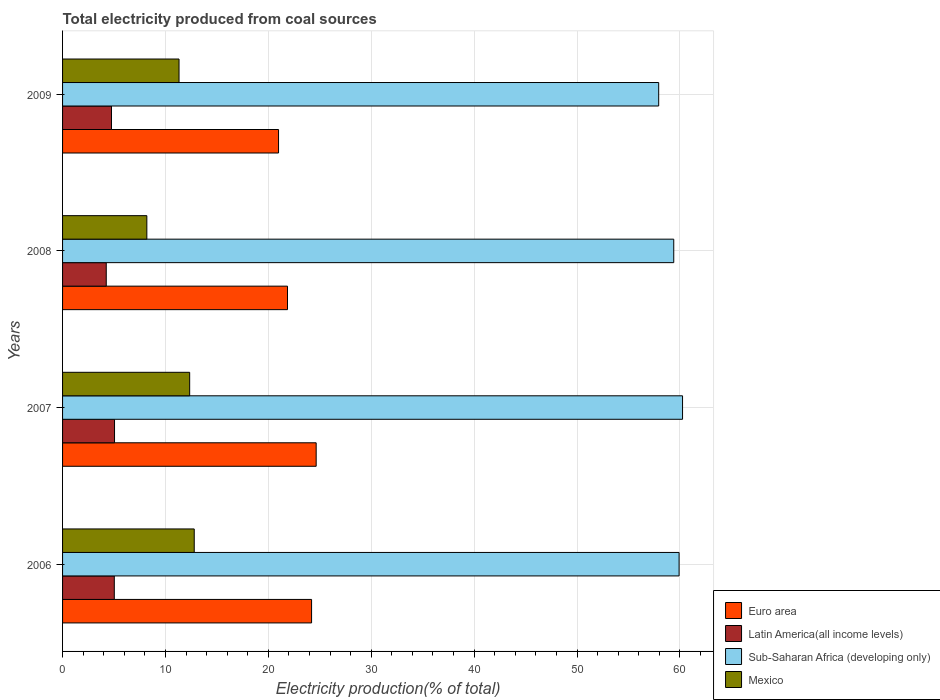How many different coloured bars are there?
Your response must be concise. 4. Are the number of bars per tick equal to the number of legend labels?
Ensure brevity in your answer.  Yes. How many bars are there on the 3rd tick from the top?
Your response must be concise. 4. How many bars are there on the 3rd tick from the bottom?
Offer a very short reply. 4. In how many cases, is the number of bars for a given year not equal to the number of legend labels?
Ensure brevity in your answer.  0. What is the total electricity produced in Sub-Saharan Africa (developing only) in 2006?
Ensure brevity in your answer.  59.92. Across all years, what is the maximum total electricity produced in Latin America(all income levels)?
Your answer should be very brief. 5.05. Across all years, what is the minimum total electricity produced in Latin America(all income levels)?
Make the answer very short. 4.25. In which year was the total electricity produced in Sub-Saharan Africa (developing only) minimum?
Offer a terse response. 2009. What is the total total electricity produced in Latin America(all income levels) in the graph?
Your answer should be very brief. 19.08. What is the difference between the total electricity produced in Latin America(all income levels) in 2007 and that in 2009?
Your answer should be compact. 0.3. What is the difference between the total electricity produced in Euro area in 2008 and the total electricity produced in Mexico in 2007?
Ensure brevity in your answer.  9.51. What is the average total electricity produced in Euro area per year?
Make the answer very short. 22.93. In the year 2009, what is the difference between the total electricity produced in Sub-Saharan Africa (developing only) and total electricity produced in Latin America(all income levels)?
Keep it short and to the point. 53.18. What is the ratio of the total electricity produced in Sub-Saharan Africa (developing only) in 2006 to that in 2009?
Your response must be concise. 1.03. Is the total electricity produced in Sub-Saharan Africa (developing only) in 2006 less than that in 2008?
Your response must be concise. No. Is the difference between the total electricity produced in Sub-Saharan Africa (developing only) in 2006 and 2009 greater than the difference between the total electricity produced in Latin America(all income levels) in 2006 and 2009?
Your answer should be very brief. Yes. What is the difference between the highest and the second highest total electricity produced in Euro area?
Offer a very short reply. 0.45. What is the difference between the highest and the lowest total electricity produced in Mexico?
Keep it short and to the point. 4.61. In how many years, is the total electricity produced in Sub-Saharan Africa (developing only) greater than the average total electricity produced in Sub-Saharan Africa (developing only) taken over all years?
Give a very brief answer. 3. What does the 1st bar from the top in 2008 represents?
Offer a very short reply. Mexico. What does the 2nd bar from the bottom in 2006 represents?
Make the answer very short. Latin America(all income levels). What is the difference between two consecutive major ticks on the X-axis?
Your answer should be compact. 10. Are the values on the major ticks of X-axis written in scientific E-notation?
Give a very brief answer. No. How many legend labels are there?
Provide a succinct answer. 4. How are the legend labels stacked?
Give a very brief answer. Vertical. What is the title of the graph?
Ensure brevity in your answer.  Total electricity produced from coal sources. What is the Electricity production(% of total) in Euro area in 2006?
Offer a very short reply. 24.2. What is the Electricity production(% of total) of Latin America(all income levels) in 2006?
Ensure brevity in your answer.  5.03. What is the Electricity production(% of total) in Sub-Saharan Africa (developing only) in 2006?
Provide a short and direct response. 59.92. What is the Electricity production(% of total) in Mexico in 2006?
Ensure brevity in your answer.  12.8. What is the Electricity production(% of total) in Euro area in 2007?
Your answer should be compact. 24.65. What is the Electricity production(% of total) in Latin America(all income levels) in 2007?
Your answer should be compact. 5.05. What is the Electricity production(% of total) of Sub-Saharan Africa (developing only) in 2007?
Your answer should be compact. 60.25. What is the Electricity production(% of total) in Mexico in 2007?
Offer a very short reply. 12.35. What is the Electricity production(% of total) in Euro area in 2008?
Ensure brevity in your answer.  21.86. What is the Electricity production(% of total) of Latin America(all income levels) in 2008?
Provide a short and direct response. 4.25. What is the Electricity production(% of total) of Sub-Saharan Africa (developing only) in 2008?
Provide a succinct answer. 59.4. What is the Electricity production(% of total) in Mexico in 2008?
Give a very brief answer. 8.19. What is the Electricity production(% of total) in Euro area in 2009?
Provide a succinct answer. 20.99. What is the Electricity production(% of total) in Latin America(all income levels) in 2009?
Your answer should be very brief. 4.75. What is the Electricity production(% of total) in Sub-Saharan Africa (developing only) in 2009?
Your response must be concise. 57.94. What is the Electricity production(% of total) in Mexico in 2009?
Ensure brevity in your answer.  11.32. Across all years, what is the maximum Electricity production(% of total) in Euro area?
Make the answer very short. 24.65. Across all years, what is the maximum Electricity production(% of total) in Latin America(all income levels)?
Provide a short and direct response. 5.05. Across all years, what is the maximum Electricity production(% of total) in Sub-Saharan Africa (developing only)?
Your response must be concise. 60.25. Across all years, what is the maximum Electricity production(% of total) in Mexico?
Your response must be concise. 12.8. Across all years, what is the minimum Electricity production(% of total) in Euro area?
Provide a short and direct response. 20.99. Across all years, what is the minimum Electricity production(% of total) in Latin America(all income levels)?
Offer a very short reply. 4.25. Across all years, what is the minimum Electricity production(% of total) in Sub-Saharan Africa (developing only)?
Provide a succinct answer. 57.94. Across all years, what is the minimum Electricity production(% of total) of Mexico?
Provide a succinct answer. 8.19. What is the total Electricity production(% of total) of Euro area in the graph?
Make the answer very short. 91.7. What is the total Electricity production(% of total) in Latin America(all income levels) in the graph?
Your answer should be very brief. 19.08. What is the total Electricity production(% of total) in Sub-Saharan Africa (developing only) in the graph?
Give a very brief answer. 237.51. What is the total Electricity production(% of total) in Mexico in the graph?
Provide a succinct answer. 44.66. What is the difference between the Electricity production(% of total) of Euro area in 2006 and that in 2007?
Your response must be concise. -0.45. What is the difference between the Electricity production(% of total) in Latin America(all income levels) in 2006 and that in 2007?
Keep it short and to the point. -0.02. What is the difference between the Electricity production(% of total) of Sub-Saharan Africa (developing only) in 2006 and that in 2007?
Make the answer very short. -0.33. What is the difference between the Electricity production(% of total) of Mexico in 2006 and that in 2007?
Keep it short and to the point. 0.44. What is the difference between the Electricity production(% of total) in Euro area in 2006 and that in 2008?
Make the answer very short. 2.34. What is the difference between the Electricity production(% of total) in Latin America(all income levels) in 2006 and that in 2008?
Provide a succinct answer. 0.78. What is the difference between the Electricity production(% of total) in Sub-Saharan Africa (developing only) in 2006 and that in 2008?
Your response must be concise. 0.52. What is the difference between the Electricity production(% of total) of Mexico in 2006 and that in 2008?
Offer a terse response. 4.61. What is the difference between the Electricity production(% of total) in Euro area in 2006 and that in 2009?
Provide a short and direct response. 3.21. What is the difference between the Electricity production(% of total) of Latin America(all income levels) in 2006 and that in 2009?
Offer a terse response. 0.27. What is the difference between the Electricity production(% of total) in Sub-Saharan Africa (developing only) in 2006 and that in 2009?
Provide a succinct answer. 1.98. What is the difference between the Electricity production(% of total) of Mexico in 2006 and that in 2009?
Your answer should be very brief. 1.48. What is the difference between the Electricity production(% of total) of Euro area in 2007 and that in 2008?
Ensure brevity in your answer.  2.79. What is the difference between the Electricity production(% of total) in Latin America(all income levels) in 2007 and that in 2008?
Provide a short and direct response. 0.8. What is the difference between the Electricity production(% of total) in Sub-Saharan Africa (developing only) in 2007 and that in 2008?
Give a very brief answer. 0.85. What is the difference between the Electricity production(% of total) of Mexico in 2007 and that in 2008?
Give a very brief answer. 4.16. What is the difference between the Electricity production(% of total) of Euro area in 2007 and that in 2009?
Provide a succinct answer. 3.66. What is the difference between the Electricity production(% of total) of Latin America(all income levels) in 2007 and that in 2009?
Give a very brief answer. 0.3. What is the difference between the Electricity production(% of total) in Sub-Saharan Africa (developing only) in 2007 and that in 2009?
Provide a short and direct response. 2.32. What is the difference between the Electricity production(% of total) of Mexico in 2007 and that in 2009?
Offer a very short reply. 1.03. What is the difference between the Electricity production(% of total) in Euro area in 2008 and that in 2009?
Give a very brief answer. 0.87. What is the difference between the Electricity production(% of total) in Latin America(all income levels) in 2008 and that in 2009?
Offer a very short reply. -0.51. What is the difference between the Electricity production(% of total) in Sub-Saharan Africa (developing only) in 2008 and that in 2009?
Give a very brief answer. 1.46. What is the difference between the Electricity production(% of total) in Mexico in 2008 and that in 2009?
Offer a terse response. -3.13. What is the difference between the Electricity production(% of total) in Euro area in 2006 and the Electricity production(% of total) in Latin America(all income levels) in 2007?
Offer a terse response. 19.15. What is the difference between the Electricity production(% of total) in Euro area in 2006 and the Electricity production(% of total) in Sub-Saharan Africa (developing only) in 2007?
Provide a succinct answer. -36.05. What is the difference between the Electricity production(% of total) in Euro area in 2006 and the Electricity production(% of total) in Mexico in 2007?
Offer a terse response. 11.85. What is the difference between the Electricity production(% of total) in Latin America(all income levels) in 2006 and the Electricity production(% of total) in Sub-Saharan Africa (developing only) in 2007?
Your answer should be compact. -55.23. What is the difference between the Electricity production(% of total) in Latin America(all income levels) in 2006 and the Electricity production(% of total) in Mexico in 2007?
Your answer should be compact. -7.33. What is the difference between the Electricity production(% of total) in Sub-Saharan Africa (developing only) in 2006 and the Electricity production(% of total) in Mexico in 2007?
Keep it short and to the point. 47.57. What is the difference between the Electricity production(% of total) in Euro area in 2006 and the Electricity production(% of total) in Latin America(all income levels) in 2008?
Ensure brevity in your answer.  19.96. What is the difference between the Electricity production(% of total) of Euro area in 2006 and the Electricity production(% of total) of Sub-Saharan Africa (developing only) in 2008?
Give a very brief answer. -35.2. What is the difference between the Electricity production(% of total) of Euro area in 2006 and the Electricity production(% of total) of Mexico in 2008?
Provide a succinct answer. 16.01. What is the difference between the Electricity production(% of total) of Latin America(all income levels) in 2006 and the Electricity production(% of total) of Sub-Saharan Africa (developing only) in 2008?
Your response must be concise. -54.37. What is the difference between the Electricity production(% of total) of Latin America(all income levels) in 2006 and the Electricity production(% of total) of Mexico in 2008?
Provide a succinct answer. -3.16. What is the difference between the Electricity production(% of total) of Sub-Saharan Africa (developing only) in 2006 and the Electricity production(% of total) of Mexico in 2008?
Your response must be concise. 51.73. What is the difference between the Electricity production(% of total) in Euro area in 2006 and the Electricity production(% of total) in Latin America(all income levels) in 2009?
Offer a very short reply. 19.45. What is the difference between the Electricity production(% of total) of Euro area in 2006 and the Electricity production(% of total) of Sub-Saharan Africa (developing only) in 2009?
Keep it short and to the point. -33.74. What is the difference between the Electricity production(% of total) in Euro area in 2006 and the Electricity production(% of total) in Mexico in 2009?
Your answer should be very brief. 12.88. What is the difference between the Electricity production(% of total) of Latin America(all income levels) in 2006 and the Electricity production(% of total) of Sub-Saharan Africa (developing only) in 2009?
Provide a succinct answer. -52.91. What is the difference between the Electricity production(% of total) in Latin America(all income levels) in 2006 and the Electricity production(% of total) in Mexico in 2009?
Make the answer very short. -6.29. What is the difference between the Electricity production(% of total) in Sub-Saharan Africa (developing only) in 2006 and the Electricity production(% of total) in Mexico in 2009?
Offer a very short reply. 48.6. What is the difference between the Electricity production(% of total) of Euro area in 2007 and the Electricity production(% of total) of Latin America(all income levels) in 2008?
Give a very brief answer. 20.4. What is the difference between the Electricity production(% of total) in Euro area in 2007 and the Electricity production(% of total) in Sub-Saharan Africa (developing only) in 2008?
Give a very brief answer. -34.75. What is the difference between the Electricity production(% of total) of Euro area in 2007 and the Electricity production(% of total) of Mexico in 2008?
Keep it short and to the point. 16.46. What is the difference between the Electricity production(% of total) of Latin America(all income levels) in 2007 and the Electricity production(% of total) of Sub-Saharan Africa (developing only) in 2008?
Your answer should be very brief. -54.35. What is the difference between the Electricity production(% of total) of Latin America(all income levels) in 2007 and the Electricity production(% of total) of Mexico in 2008?
Offer a very short reply. -3.14. What is the difference between the Electricity production(% of total) of Sub-Saharan Africa (developing only) in 2007 and the Electricity production(% of total) of Mexico in 2008?
Your answer should be compact. 52.06. What is the difference between the Electricity production(% of total) of Euro area in 2007 and the Electricity production(% of total) of Latin America(all income levels) in 2009?
Provide a succinct answer. 19.89. What is the difference between the Electricity production(% of total) of Euro area in 2007 and the Electricity production(% of total) of Sub-Saharan Africa (developing only) in 2009?
Provide a succinct answer. -33.29. What is the difference between the Electricity production(% of total) in Euro area in 2007 and the Electricity production(% of total) in Mexico in 2009?
Your answer should be compact. 13.33. What is the difference between the Electricity production(% of total) of Latin America(all income levels) in 2007 and the Electricity production(% of total) of Sub-Saharan Africa (developing only) in 2009?
Offer a terse response. -52.89. What is the difference between the Electricity production(% of total) in Latin America(all income levels) in 2007 and the Electricity production(% of total) in Mexico in 2009?
Offer a terse response. -6.27. What is the difference between the Electricity production(% of total) in Sub-Saharan Africa (developing only) in 2007 and the Electricity production(% of total) in Mexico in 2009?
Your answer should be compact. 48.94. What is the difference between the Electricity production(% of total) of Euro area in 2008 and the Electricity production(% of total) of Latin America(all income levels) in 2009?
Your response must be concise. 17.11. What is the difference between the Electricity production(% of total) in Euro area in 2008 and the Electricity production(% of total) in Sub-Saharan Africa (developing only) in 2009?
Your response must be concise. -36.08. What is the difference between the Electricity production(% of total) in Euro area in 2008 and the Electricity production(% of total) in Mexico in 2009?
Offer a very short reply. 10.54. What is the difference between the Electricity production(% of total) of Latin America(all income levels) in 2008 and the Electricity production(% of total) of Sub-Saharan Africa (developing only) in 2009?
Give a very brief answer. -53.69. What is the difference between the Electricity production(% of total) in Latin America(all income levels) in 2008 and the Electricity production(% of total) in Mexico in 2009?
Your answer should be compact. -7.07. What is the difference between the Electricity production(% of total) in Sub-Saharan Africa (developing only) in 2008 and the Electricity production(% of total) in Mexico in 2009?
Your answer should be compact. 48.08. What is the average Electricity production(% of total) of Euro area per year?
Your answer should be compact. 22.93. What is the average Electricity production(% of total) in Latin America(all income levels) per year?
Provide a succinct answer. 4.77. What is the average Electricity production(% of total) in Sub-Saharan Africa (developing only) per year?
Offer a terse response. 59.38. What is the average Electricity production(% of total) of Mexico per year?
Provide a succinct answer. 11.17. In the year 2006, what is the difference between the Electricity production(% of total) in Euro area and Electricity production(% of total) in Latin America(all income levels)?
Your answer should be very brief. 19.17. In the year 2006, what is the difference between the Electricity production(% of total) of Euro area and Electricity production(% of total) of Sub-Saharan Africa (developing only)?
Ensure brevity in your answer.  -35.72. In the year 2006, what is the difference between the Electricity production(% of total) of Euro area and Electricity production(% of total) of Mexico?
Keep it short and to the point. 11.4. In the year 2006, what is the difference between the Electricity production(% of total) of Latin America(all income levels) and Electricity production(% of total) of Sub-Saharan Africa (developing only)?
Give a very brief answer. -54.89. In the year 2006, what is the difference between the Electricity production(% of total) in Latin America(all income levels) and Electricity production(% of total) in Mexico?
Provide a short and direct response. -7.77. In the year 2006, what is the difference between the Electricity production(% of total) in Sub-Saharan Africa (developing only) and Electricity production(% of total) in Mexico?
Ensure brevity in your answer.  47.12. In the year 2007, what is the difference between the Electricity production(% of total) in Euro area and Electricity production(% of total) in Latin America(all income levels)?
Offer a very short reply. 19.6. In the year 2007, what is the difference between the Electricity production(% of total) in Euro area and Electricity production(% of total) in Sub-Saharan Africa (developing only)?
Provide a short and direct response. -35.61. In the year 2007, what is the difference between the Electricity production(% of total) in Euro area and Electricity production(% of total) in Mexico?
Your answer should be compact. 12.29. In the year 2007, what is the difference between the Electricity production(% of total) of Latin America(all income levels) and Electricity production(% of total) of Sub-Saharan Africa (developing only)?
Give a very brief answer. -55.2. In the year 2007, what is the difference between the Electricity production(% of total) of Latin America(all income levels) and Electricity production(% of total) of Mexico?
Your answer should be very brief. -7.3. In the year 2007, what is the difference between the Electricity production(% of total) in Sub-Saharan Africa (developing only) and Electricity production(% of total) in Mexico?
Offer a terse response. 47.9. In the year 2008, what is the difference between the Electricity production(% of total) of Euro area and Electricity production(% of total) of Latin America(all income levels)?
Your answer should be compact. 17.62. In the year 2008, what is the difference between the Electricity production(% of total) in Euro area and Electricity production(% of total) in Sub-Saharan Africa (developing only)?
Your answer should be compact. -37.54. In the year 2008, what is the difference between the Electricity production(% of total) of Euro area and Electricity production(% of total) of Mexico?
Your response must be concise. 13.67. In the year 2008, what is the difference between the Electricity production(% of total) in Latin America(all income levels) and Electricity production(% of total) in Sub-Saharan Africa (developing only)?
Ensure brevity in your answer.  -55.15. In the year 2008, what is the difference between the Electricity production(% of total) of Latin America(all income levels) and Electricity production(% of total) of Mexico?
Make the answer very short. -3.94. In the year 2008, what is the difference between the Electricity production(% of total) in Sub-Saharan Africa (developing only) and Electricity production(% of total) in Mexico?
Your answer should be compact. 51.21. In the year 2009, what is the difference between the Electricity production(% of total) of Euro area and Electricity production(% of total) of Latin America(all income levels)?
Your answer should be compact. 16.24. In the year 2009, what is the difference between the Electricity production(% of total) in Euro area and Electricity production(% of total) in Sub-Saharan Africa (developing only)?
Provide a succinct answer. -36.95. In the year 2009, what is the difference between the Electricity production(% of total) in Euro area and Electricity production(% of total) in Mexico?
Make the answer very short. 9.67. In the year 2009, what is the difference between the Electricity production(% of total) of Latin America(all income levels) and Electricity production(% of total) of Sub-Saharan Africa (developing only)?
Keep it short and to the point. -53.18. In the year 2009, what is the difference between the Electricity production(% of total) in Latin America(all income levels) and Electricity production(% of total) in Mexico?
Give a very brief answer. -6.57. In the year 2009, what is the difference between the Electricity production(% of total) in Sub-Saharan Africa (developing only) and Electricity production(% of total) in Mexico?
Provide a succinct answer. 46.62. What is the ratio of the Electricity production(% of total) of Euro area in 2006 to that in 2007?
Ensure brevity in your answer.  0.98. What is the ratio of the Electricity production(% of total) of Mexico in 2006 to that in 2007?
Your answer should be compact. 1.04. What is the ratio of the Electricity production(% of total) in Euro area in 2006 to that in 2008?
Provide a succinct answer. 1.11. What is the ratio of the Electricity production(% of total) in Latin America(all income levels) in 2006 to that in 2008?
Provide a short and direct response. 1.18. What is the ratio of the Electricity production(% of total) in Sub-Saharan Africa (developing only) in 2006 to that in 2008?
Make the answer very short. 1.01. What is the ratio of the Electricity production(% of total) in Mexico in 2006 to that in 2008?
Offer a terse response. 1.56. What is the ratio of the Electricity production(% of total) of Euro area in 2006 to that in 2009?
Give a very brief answer. 1.15. What is the ratio of the Electricity production(% of total) in Latin America(all income levels) in 2006 to that in 2009?
Provide a succinct answer. 1.06. What is the ratio of the Electricity production(% of total) in Sub-Saharan Africa (developing only) in 2006 to that in 2009?
Offer a very short reply. 1.03. What is the ratio of the Electricity production(% of total) of Mexico in 2006 to that in 2009?
Provide a short and direct response. 1.13. What is the ratio of the Electricity production(% of total) of Euro area in 2007 to that in 2008?
Offer a terse response. 1.13. What is the ratio of the Electricity production(% of total) of Latin America(all income levels) in 2007 to that in 2008?
Your answer should be very brief. 1.19. What is the ratio of the Electricity production(% of total) in Sub-Saharan Africa (developing only) in 2007 to that in 2008?
Keep it short and to the point. 1.01. What is the ratio of the Electricity production(% of total) in Mexico in 2007 to that in 2008?
Provide a short and direct response. 1.51. What is the ratio of the Electricity production(% of total) of Euro area in 2007 to that in 2009?
Provide a short and direct response. 1.17. What is the ratio of the Electricity production(% of total) of Latin America(all income levels) in 2007 to that in 2009?
Your response must be concise. 1.06. What is the ratio of the Electricity production(% of total) of Sub-Saharan Africa (developing only) in 2007 to that in 2009?
Keep it short and to the point. 1.04. What is the ratio of the Electricity production(% of total) in Mexico in 2007 to that in 2009?
Your answer should be very brief. 1.09. What is the ratio of the Electricity production(% of total) in Euro area in 2008 to that in 2009?
Ensure brevity in your answer.  1.04. What is the ratio of the Electricity production(% of total) in Latin America(all income levels) in 2008 to that in 2009?
Offer a terse response. 0.89. What is the ratio of the Electricity production(% of total) in Sub-Saharan Africa (developing only) in 2008 to that in 2009?
Your answer should be very brief. 1.03. What is the ratio of the Electricity production(% of total) in Mexico in 2008 to that in 2009?
Provide a short and direct response. 0.72. What is the difference between the highest and the second highest Electricity production(% of total) in Euro area?
Give a very brief answer. 0.45. What is the difference between the highest and the second highest Electricity production(% of total) in Latin America(all income levels)?
Provide a succinct answer. 0.02. What is the difference between the highest and the second highest Electricity production(% of total) in Sub-Saharan Africa (developing only)?
Provide a succinct answer. 0.33. What is the difference between the highest and the second highest Electricity production(% of total) of Mexico?
Offer a terse response. 0.44. What is the difference between the highest and the lowest Electricity production(% of total) of Euro area?
Your answer should be very brief. 3.66. What is the difference between the highest and the lowest Electricity production(% of total) in Latin America(all income levels)?
Ensure brevity in your answer.  0.8. What is the difference between the highest and the lowest Electricity production(% of total) in Sub-Saharan Africa (developing only)?
Keep it short and to the point. 2.32. What is the difference between the highest and the lowest Electricity production(% of total) of Mexico?
Your response must be concise. 4.61. 